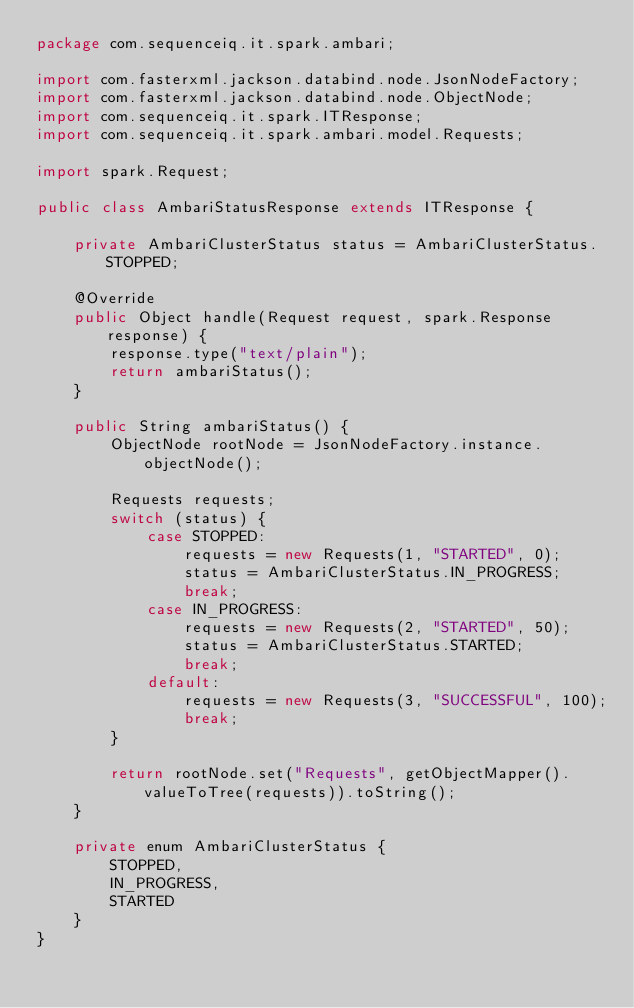<code> <loc_0><loc_0><loc_500><loc_500><_Java_>package com.sequenceiq.it.spark.ambari;

import com.fasterxml.jackson.databind.node.JsonNodeFactory;
import com.fasterxml.jackson.databind.node.ObjectNode;
import com.sequenceiq.it.spark.ITResponse;
import com.sequenceiq.it.spark.ambari.model.Requests;

import spark.Request;

public class AmbariStatusResponse extends ITResponse {

    private AmbariClusterStatus status = AmbariClusterStatus.STOPPED;

    @Override
    public Object handle(Request request, spark.Response response) {
        response.type("text/plain");
        return ambariStatus();
    }

    public String ambariStatus() {
        ObjectNode rootNode = JsonNodeFactory.instance.objectNode();

        Requests requests;
        switch (status) {
            case STOPPED:
                requests = new Requests(1, "STARTED", 0);
                status = AmbariClusterStatus.IN_PROGRESS;
                break;
            case IN_PROGRESS:
                requests = new Requests(2, "STARTED", 50);
                status = AmbariClusterStatus.STARTED;
                break;
            default:
                requests = new Requests(3, "SUCCESSFUL", 100);
                break;
        }

        return rootNode.set("Requests", getObjectMapper().valueToTree(requests)).toString();
    }

    private enum AmbariClusterStatus {
        STOPPED,
        IN_PROGRESS,
        STARTED
    }
}
</code> 